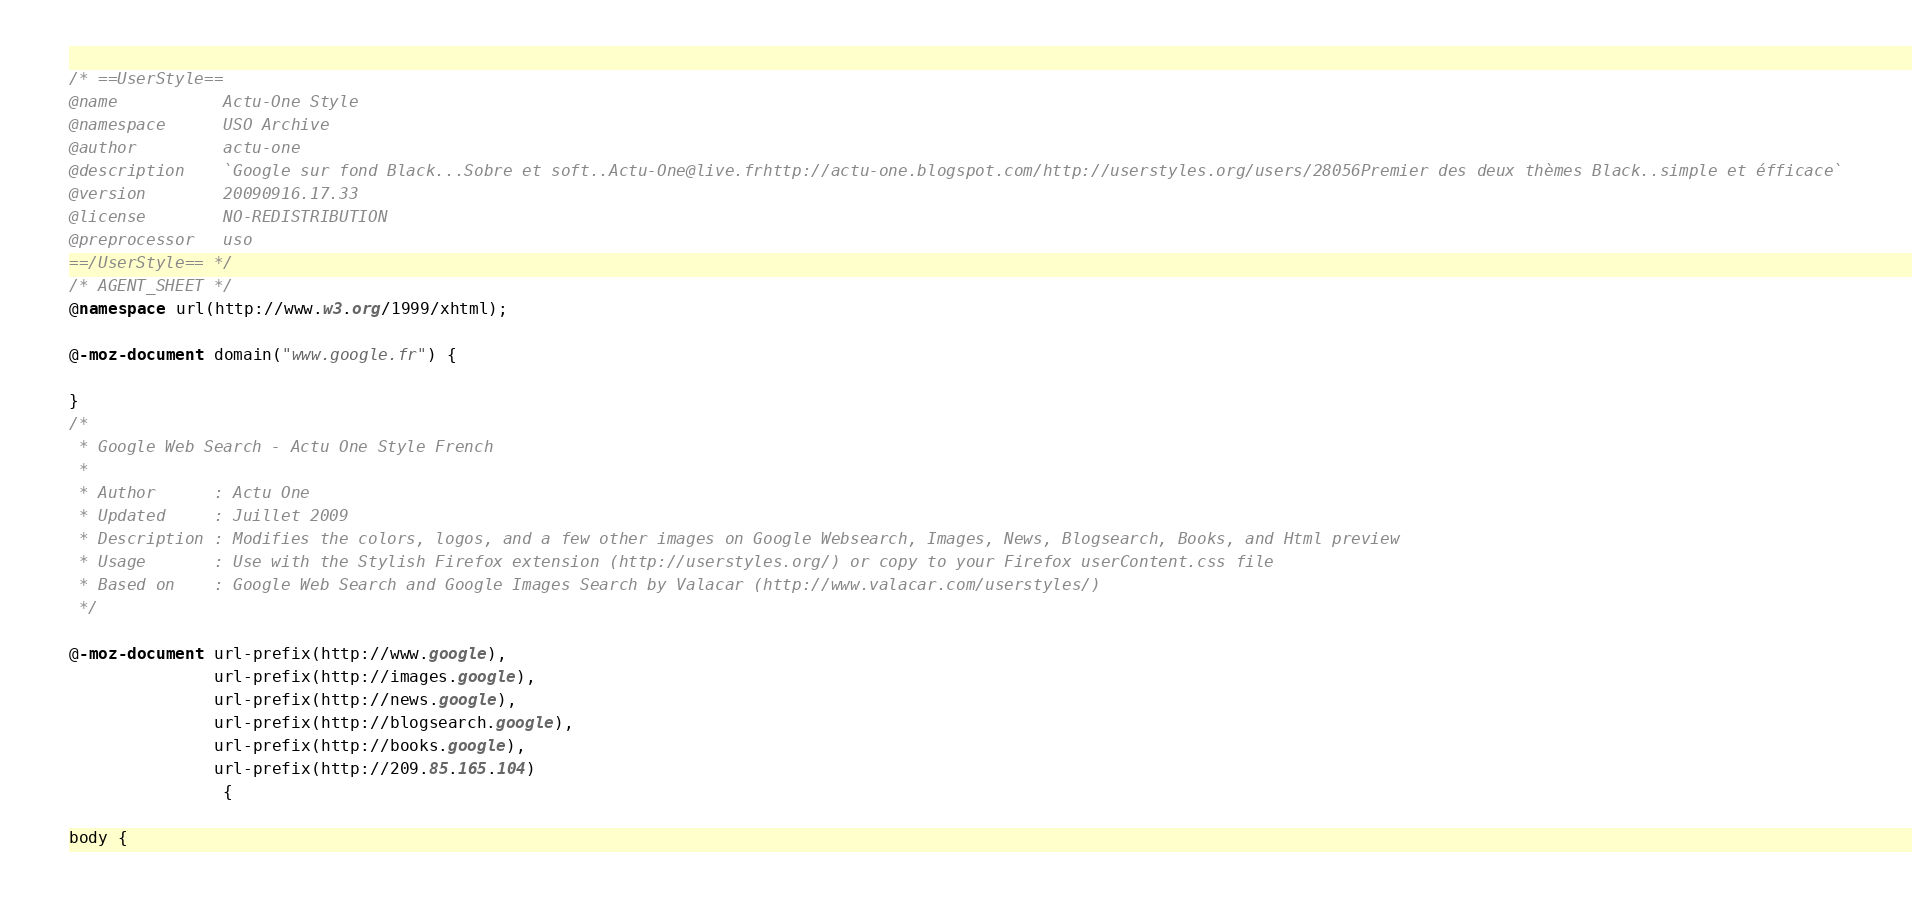Convert code to text. <code><loc_0><loc_0><loc_500><loc_500><_CSS_>/* ==UserStyle==
@name           Actu-One Style
@namespace      USO Archive
@author         actu-one
@description    `Google sur fond Black...Sobre et soft..Actu-One@live.frhttp://actu-one.blogspot.com/http://userstyles.org/users/28056Premier des deux thèmes Black..simple et éfficace`
@version        20090916.17.33
@license        NO-REDISTRIBUTION
@preprocessor   uso
==/UserStyle== */
/* AGENT_SHEET */
@namespace url(http://www.w3.org/1999/xhtml);

@-moz-document domain("www.google.fr") {

}
/*
 * Google Web Search - Actu One Style French
 *
 * Author      : Actu One
 * Updated     : Juillet 2009
 * Description : Modifies the colors, logos, and a few other images on Google Websearch, Images, News, Blogsearch, Books, and Html preview
 * Usage       : Use with the Stylish Firefox extension (http://userstyles.org/) or copy to your Firefox userContent.css file
 * Based on    : Google Web Search and Google Images Search by Valacar (http://www.valacar.com/userstyles/)
 */

@-moz-document url-prefix(http://www.google),
               url-prefix(http://images.google),
               url-prefix(http://news.google),
               url-prefix(http://blogsearch.google),
               url-prefix(http://books.google),
               url-prefix(http://209.85.165.104)
                {

body {</code> 